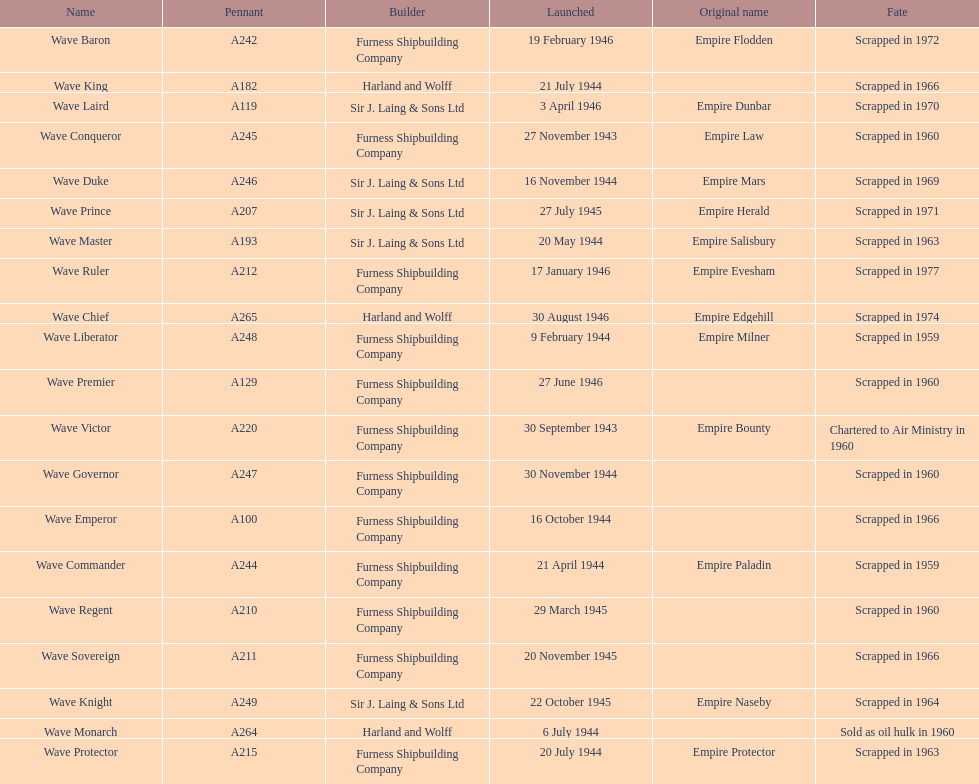Which other ship was launched in the same year as the wave victor? Wave Conqueror. 